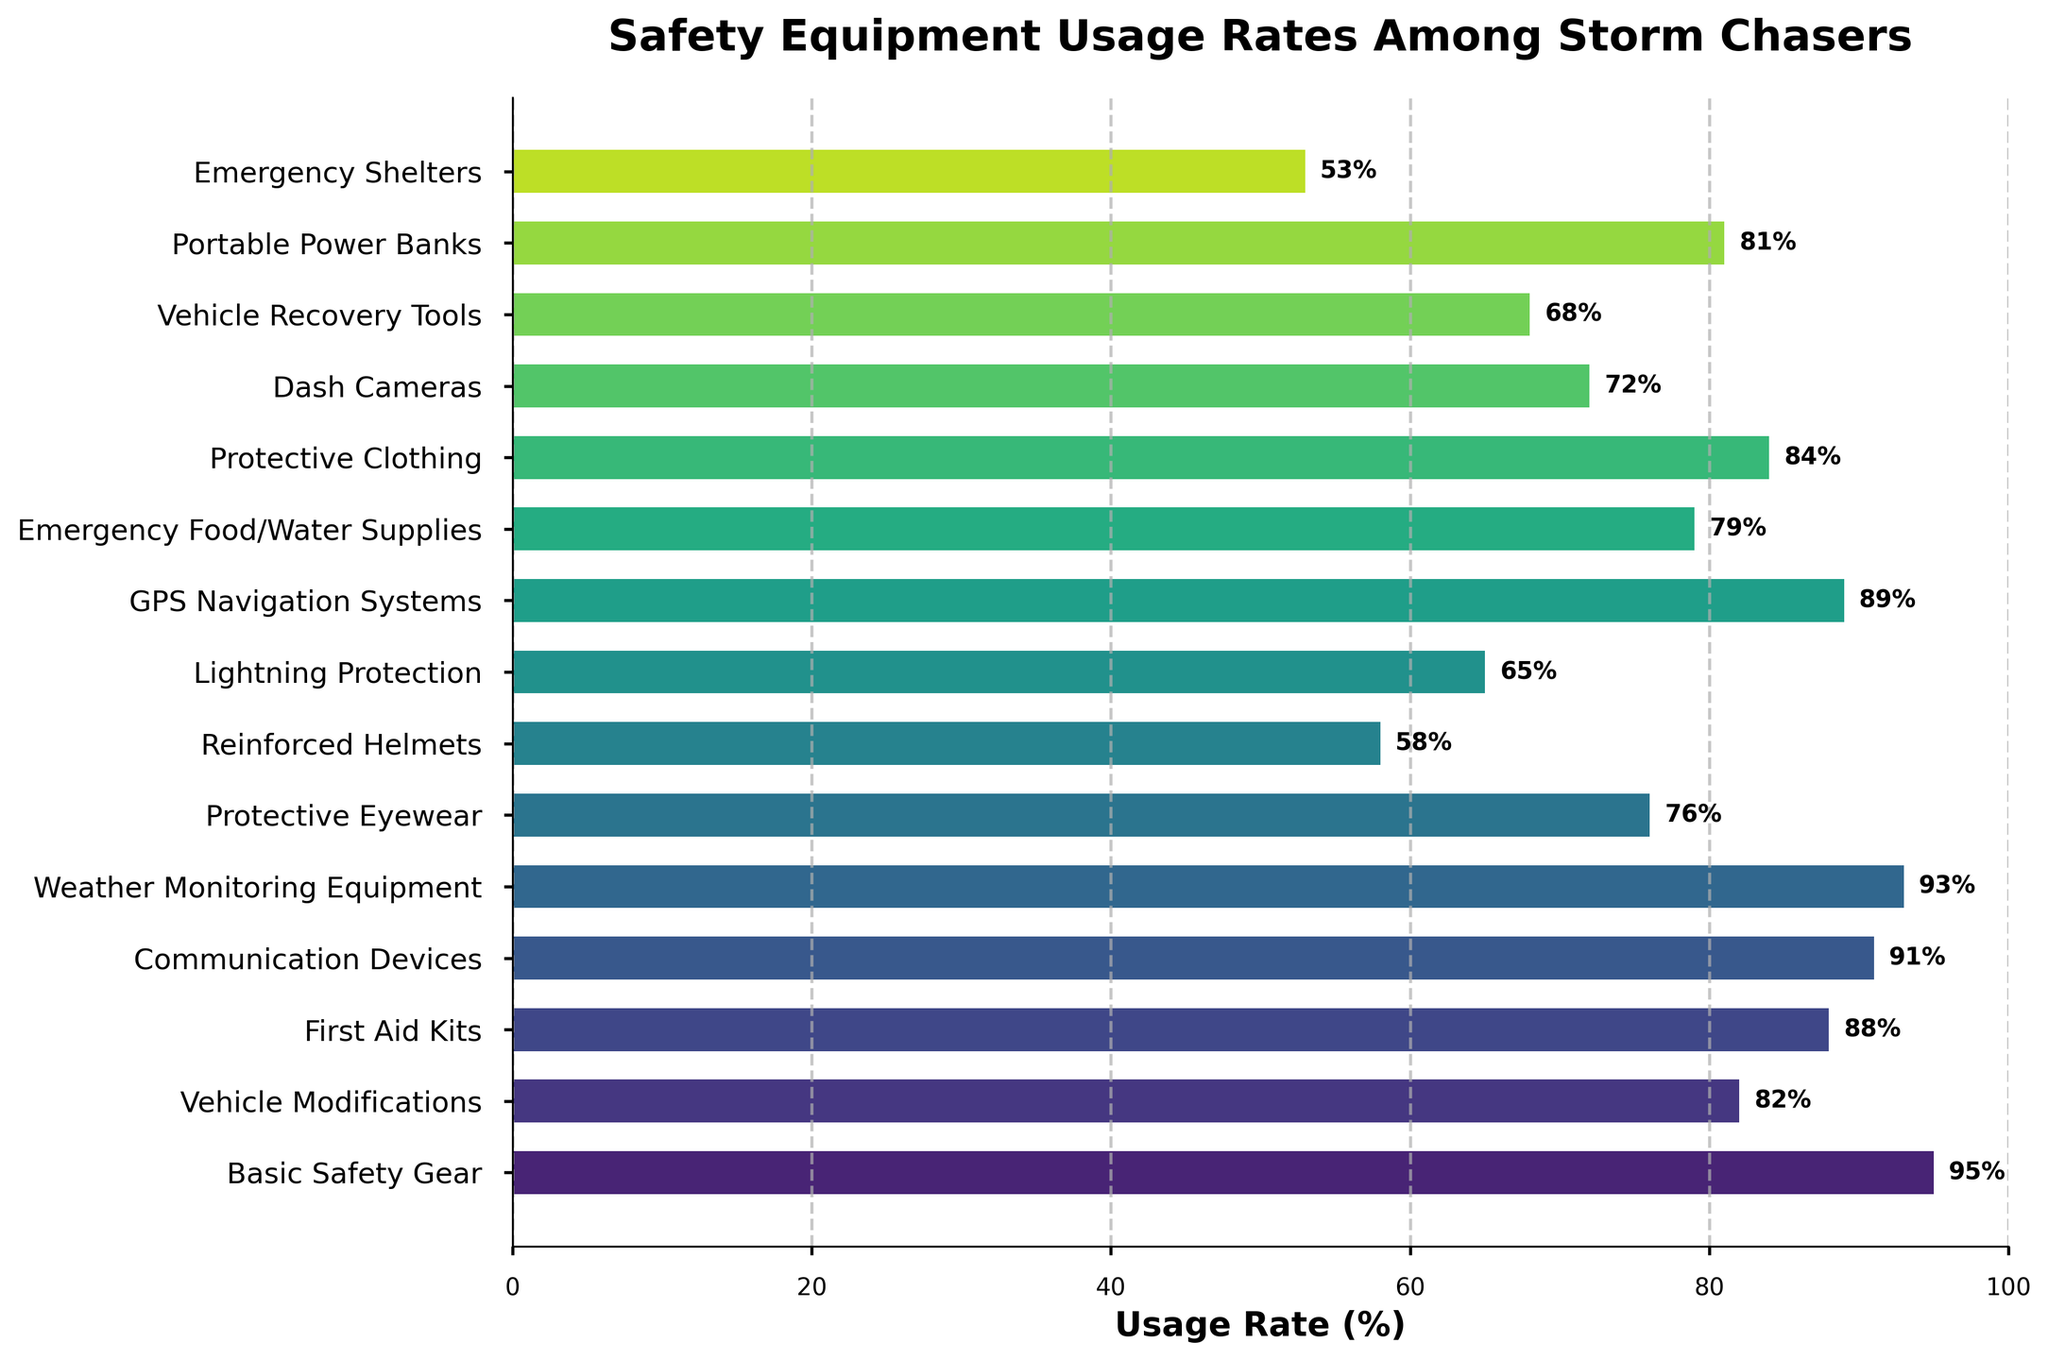What's the most commonly used safety equipment category among storm chasers? The category with the highest usage rate percentage is the most commonly used. Here, "Basic Safety Gear" has the highest usage rate at 95%.
Answer: Basic Safety Gear Which safety equipment has the lowest usage rate among storm chasers? The category with the lowest usage rate percentage is the least used. "Emergency Shelters" has the lowest usage rate at 53%.
Answer: Emergency Shelters How many safety equipment categories have a usage rate above 80%? Count the categories with usage rates greater than 80%. They are "Basic Safety Gear," "Vehicle Modifications," "First Aid Kits," "Communication Devices," "Weather Monitoring Equipment," and "GPS Navigation Systems," totaling 6.
Answer: 6 What is the average usage rate of all safety equipment categories? Add the usage rates of all categories and divide by the number of categories: (95 + 82 + 88 + 91 + 93 + 76 + 58 + 65 + 89 + 79 + 84 + 72 + 68 + 81 + 53) / 15 = 80.27%.
Answer: 80.27% Which has a higher usage rate, Protective Eyewear or Emergency Food/Water Supplies? Compare the usage rates of "Protective Eyewear" (76%) and "Emergency Food/Water Supplies" (79%). "Emergency Food/Water Supplies" has a higher rate.
Answer: Emergency Food/Water Supplies How much higher is the usage rate of Weather Monitoring Equipment compared to Lightning Protection? Subtract the usage rate of "Lightning Protection" (65%) from "Weather Monitoring Equipment" (93%): 93% - 65% = 28%.
Answer: 28% Are there more categories with usage rates above or below 75%? Count categories with usage rates above 75% (9 categories) and compare with those below 75% (6 categories). There are more above.
Answer: Above Which category, Dash Cameras or First Aid Kits, has a usage rate closer to 70%? Compare how close the usage rate of each category is to 70%. "Dash Cameras" has a usage rate of 72%, whereas "First Aid Kits" has a usage rate of 88%. Thus, "Dash Cameras" is closer.
Answer: Dash Cameras What is the median usage rate among all safety equipment categories? The median is the middle value when the usage rates are ordered. Ordered rates: 53, 58, 65, 68, 72, 76, 79, 81, 82, 84, 88, 89, 91, 93, 95. The median is the 8th value: 81%.
Answer: 81% How do the usage rates of the top 3 most commonly used categories compare to each other? The top 3 categories are "Basic Safety Gear" (95%), "Weather Monitoring Equipment" (93%), and "Communication Devices" (91%). Compare their usage rates in descending order: 95% > 93% > 91%.
Answer: 95% > 93% > 91% 